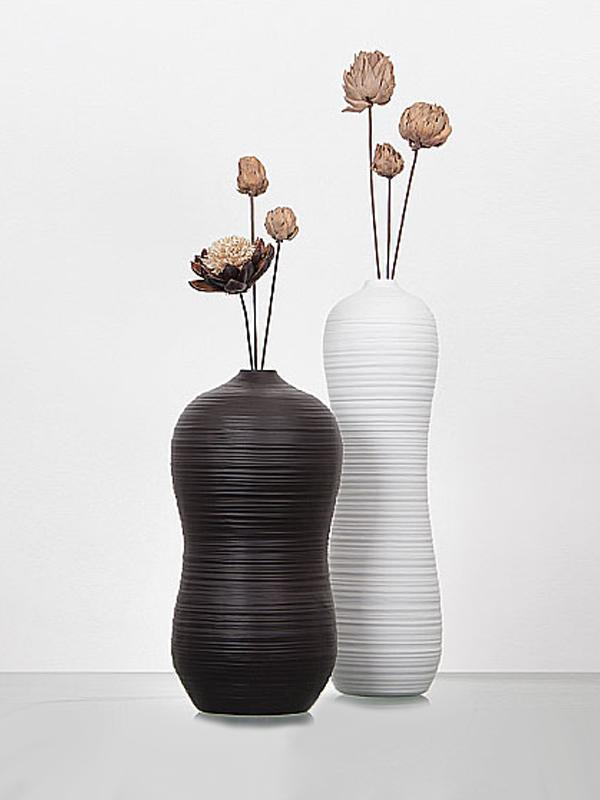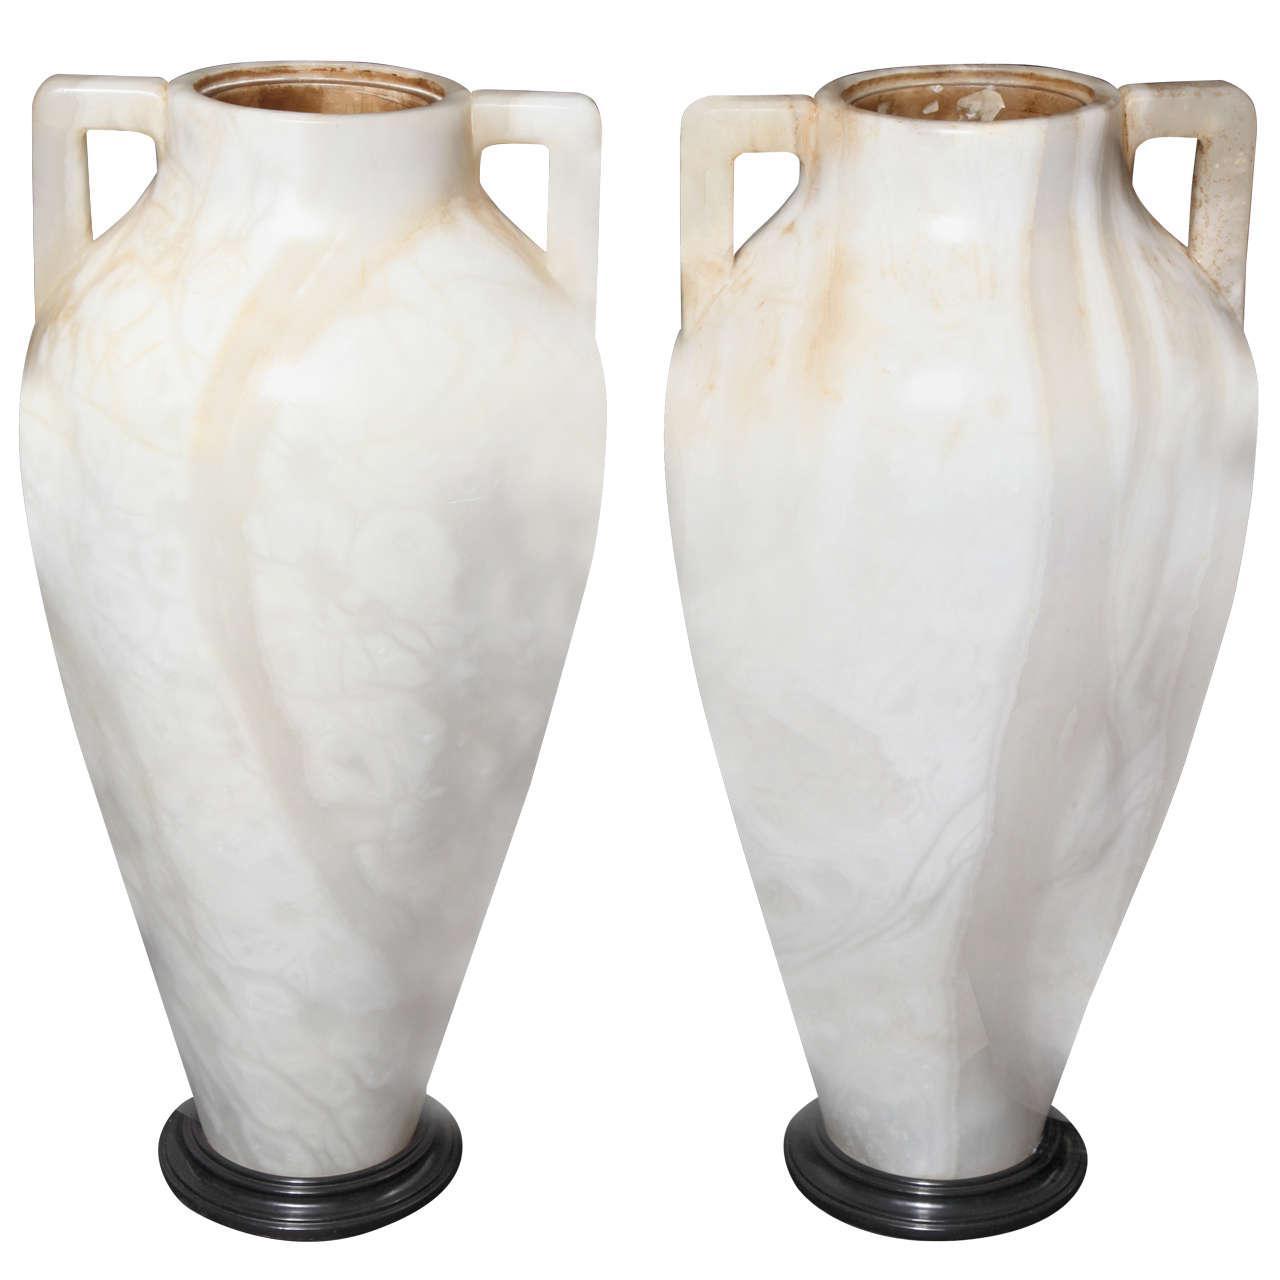The first image is the image on the left, the second image is the image on the right. For the images shown, is this caption "One vase is the exact size and shape as another one of the vases." true? Answer yes or no. Yes. The first image is the image on the left, the second image is the image on the right. Given the left and right images, does the statement "In one of the image there is a black vase with a flower sticking out." hold true? Answer yes or no. Yes. 